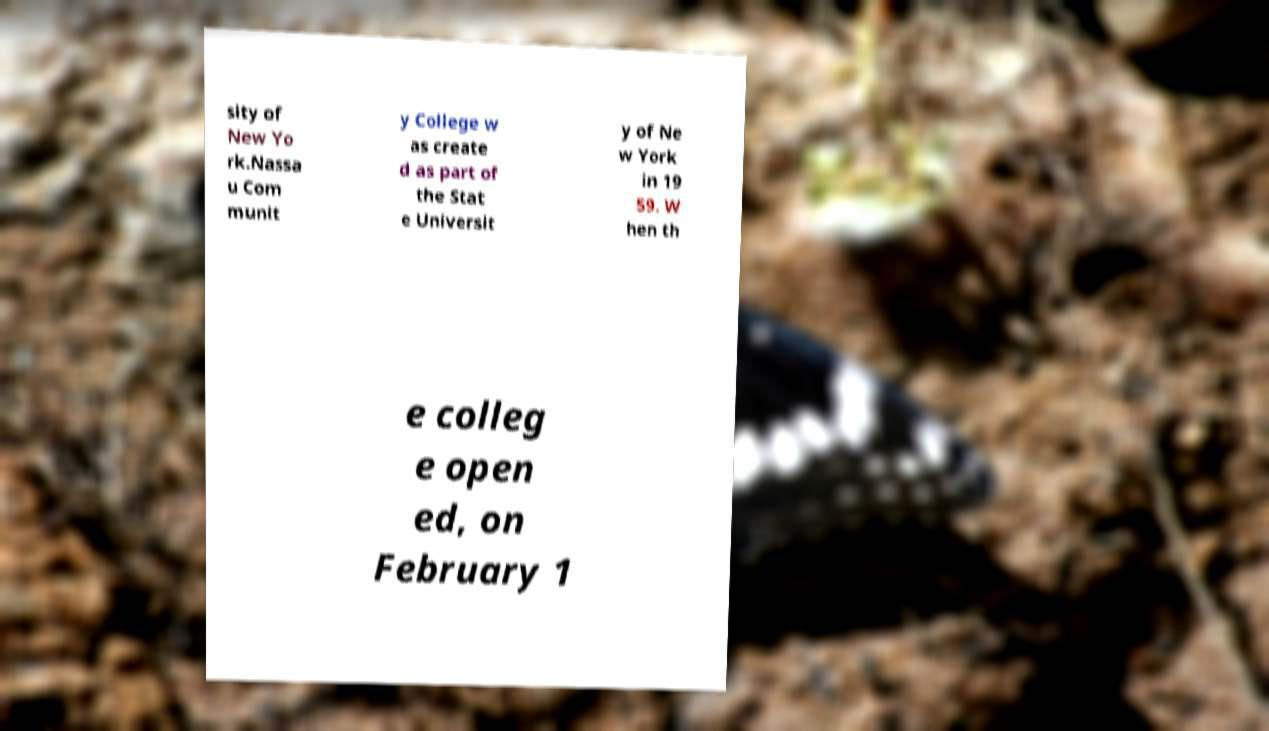There's text embedded in this image that I need extracted. Can you transcribe it verbatim? sity of New Yo rk.Nassa u Com munit y College w as create d as part of the Stat e Universit y of Ne w York in 19 59. W hen th e colleg e open ed, on February 1 